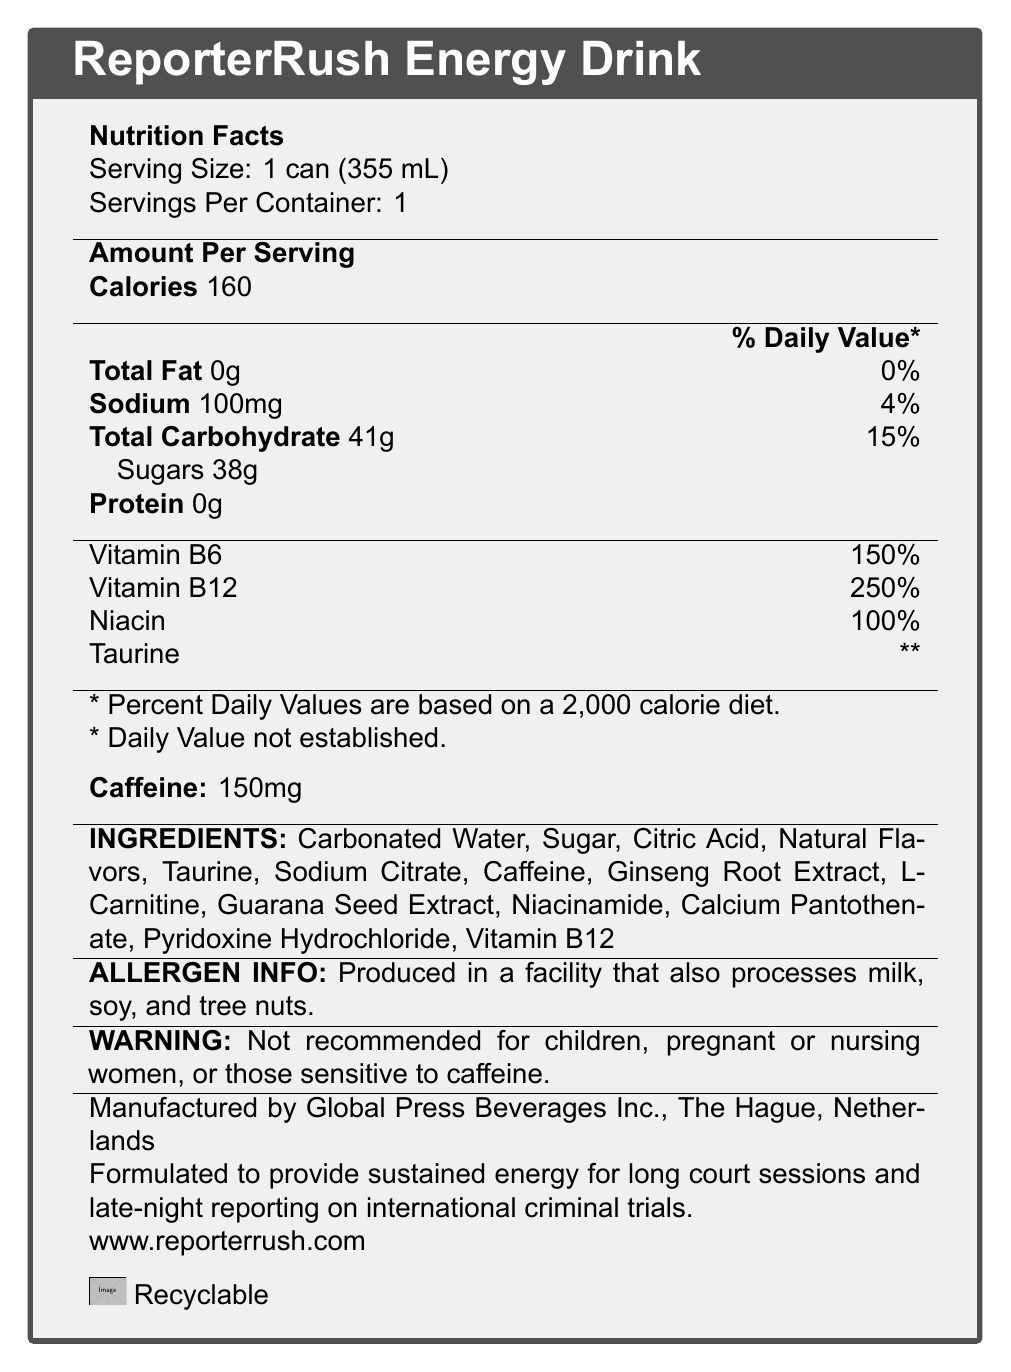What is the serving size of ReporterRush Energy Drink? The serving size is directly stated as "1 can (355 mL)."
Answer: 1 can (355 mL) How many calories are in one serving of ReporterRush Energy Drink? The amount of calories per serving is explicitly mentioned as 160.
Answer: 160 How much sodium does the ReporterRush Energy Drink contain per serving? The sodium content per serving is listed as 100mg.
Answer: 100mg List two main vitamins found in the ReporterRush Energy Drink and their corresponding daily value percentages. The document lists Vitamin B6 with 150% of the daily value and Vitamin B12 with 250% of the daily value.
Answer: Vitamin B6: 150%, Vitamin B12: 250% What is the caffeine content per serving in ReporterRush Energy Drink? The caffeine content per serving is specifically given as 150mg.
Answer: 150mg Which company manufactures the ReporterRush Energy Drink? The manufacturer is listed as Global Press Beverages Inc.
Answer: Global Press Beverages Inc. What is the main warning mentioned regarding the consumption of ReporterRush Energy Drink? This warning is clearly stated under the "WARNING" section of the document.
Answer: Not recommended for children, pregnant or nursing women, or those sensitive to caffeine. How many grams of sugars are contained in one serving of ReporterRush Energy Drink? The sugar content per serving is listed as 38g.
Answer: 38g Which of the following ingredients is NOT found in ReporterRush Energy Drink? A. Sugar B. Taurine C. Aspartame D. L-Carnitine Aspartame is not listed among the ingredients; the main ingredients listed include Sugar, Taurine, and L-Carnitine.
Answer: C. Aspartame What vitamin is responsible for 100% of the daily value in ReporterRush Energy Drink? A. Vitamin B6 B. Vitamin B12 C. Niacin D. Taurine Niacin is listed with a 100% daily value.
Answer: C. Niacin Is the ReporterRush Energy Drink suitable for children and pregnant women? The warning states that it is not recommended for children, pregnant or nursing women, or those sensitive to caffeine.
Answer: No Summarize the main idea of the ReporterRush Energy Drink nutrition facts label. The document contains detailed nutritional information, the manufacturer, ingredients, allergen info, specific warnings, and its purpose tailored for journalists needing sustained energy.
Answer: The ReporterRush Energy Drink is designed to provide energy for long court sessions and late-night reporting, containing 160 calories, 150mg of caffeine, significant amounts of Vitamin B6 and B12, and other ingredients like Taurine and Ginseng Root Extract. It includes a warning for children, pregnant or nursing women, and those sensitive to caffeine. The drink is produced by Global Press Beverages Inc. and is notably high in sugars and certain vitamins. What is the daily value percentage of Sodium in ReporterRush Energy Drink? The sodium content per serving is 100mg, which corresponds to 4% of the daily value.
Answer: 4% Can the daily value of Taurine in ReporterRush Energy Drink be determined from the document? The document states "** Daily Value not established" for Taurine, indicating that the daily value is not provided.
Answer: No 